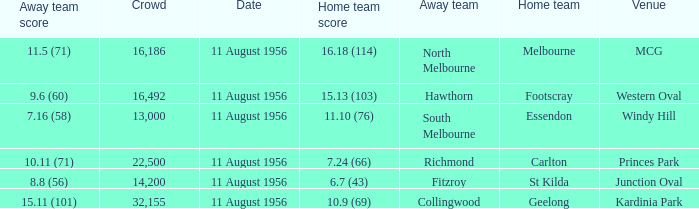What is the home team score for Footscray? 15.13 (103). 